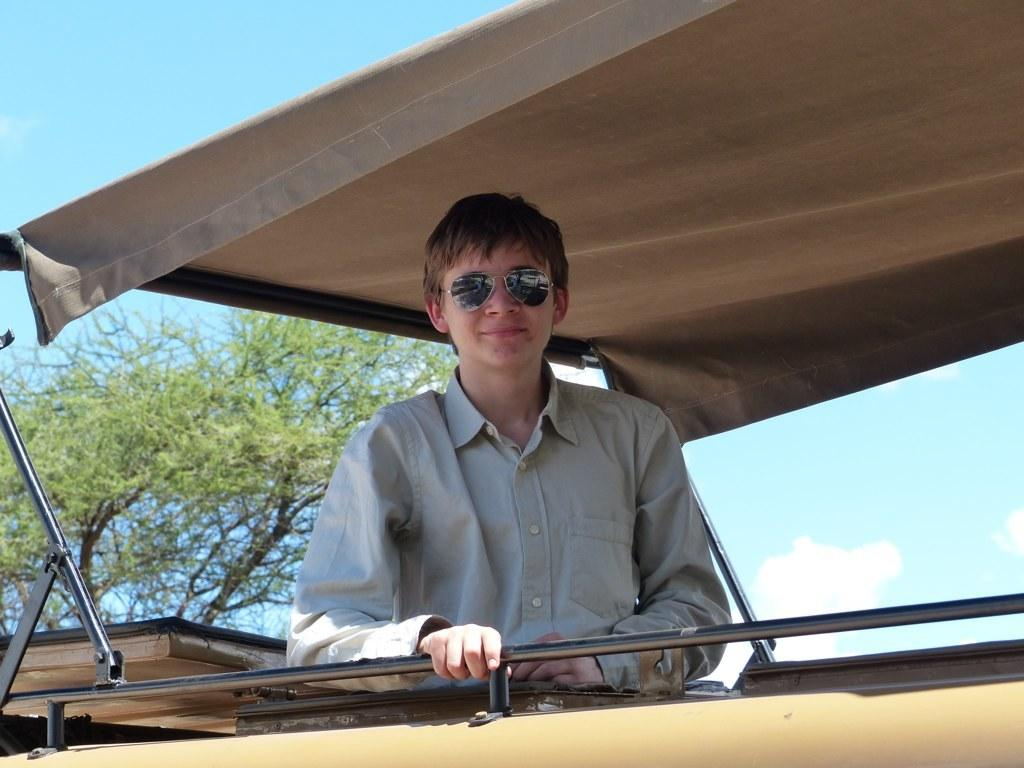Who is the main subject in the image? There is a person in the center of the image. What accessory is the person wearing? The person is wearing glasses. Where is the person located in the image? The person is under a roof. What can be seen in the background of the image? There are trees and the sky visible in the background of the image. What is the condition of the sky in the image? The sky has clouds in it. What type of prison is depicted in the image? There is no prison present in the image; it features a person under a roof with trees and clouds in the background. What fact can be determined about the person's ability to limit their actions in the image? There is no information about the person's ability to limit their actions in the image. 